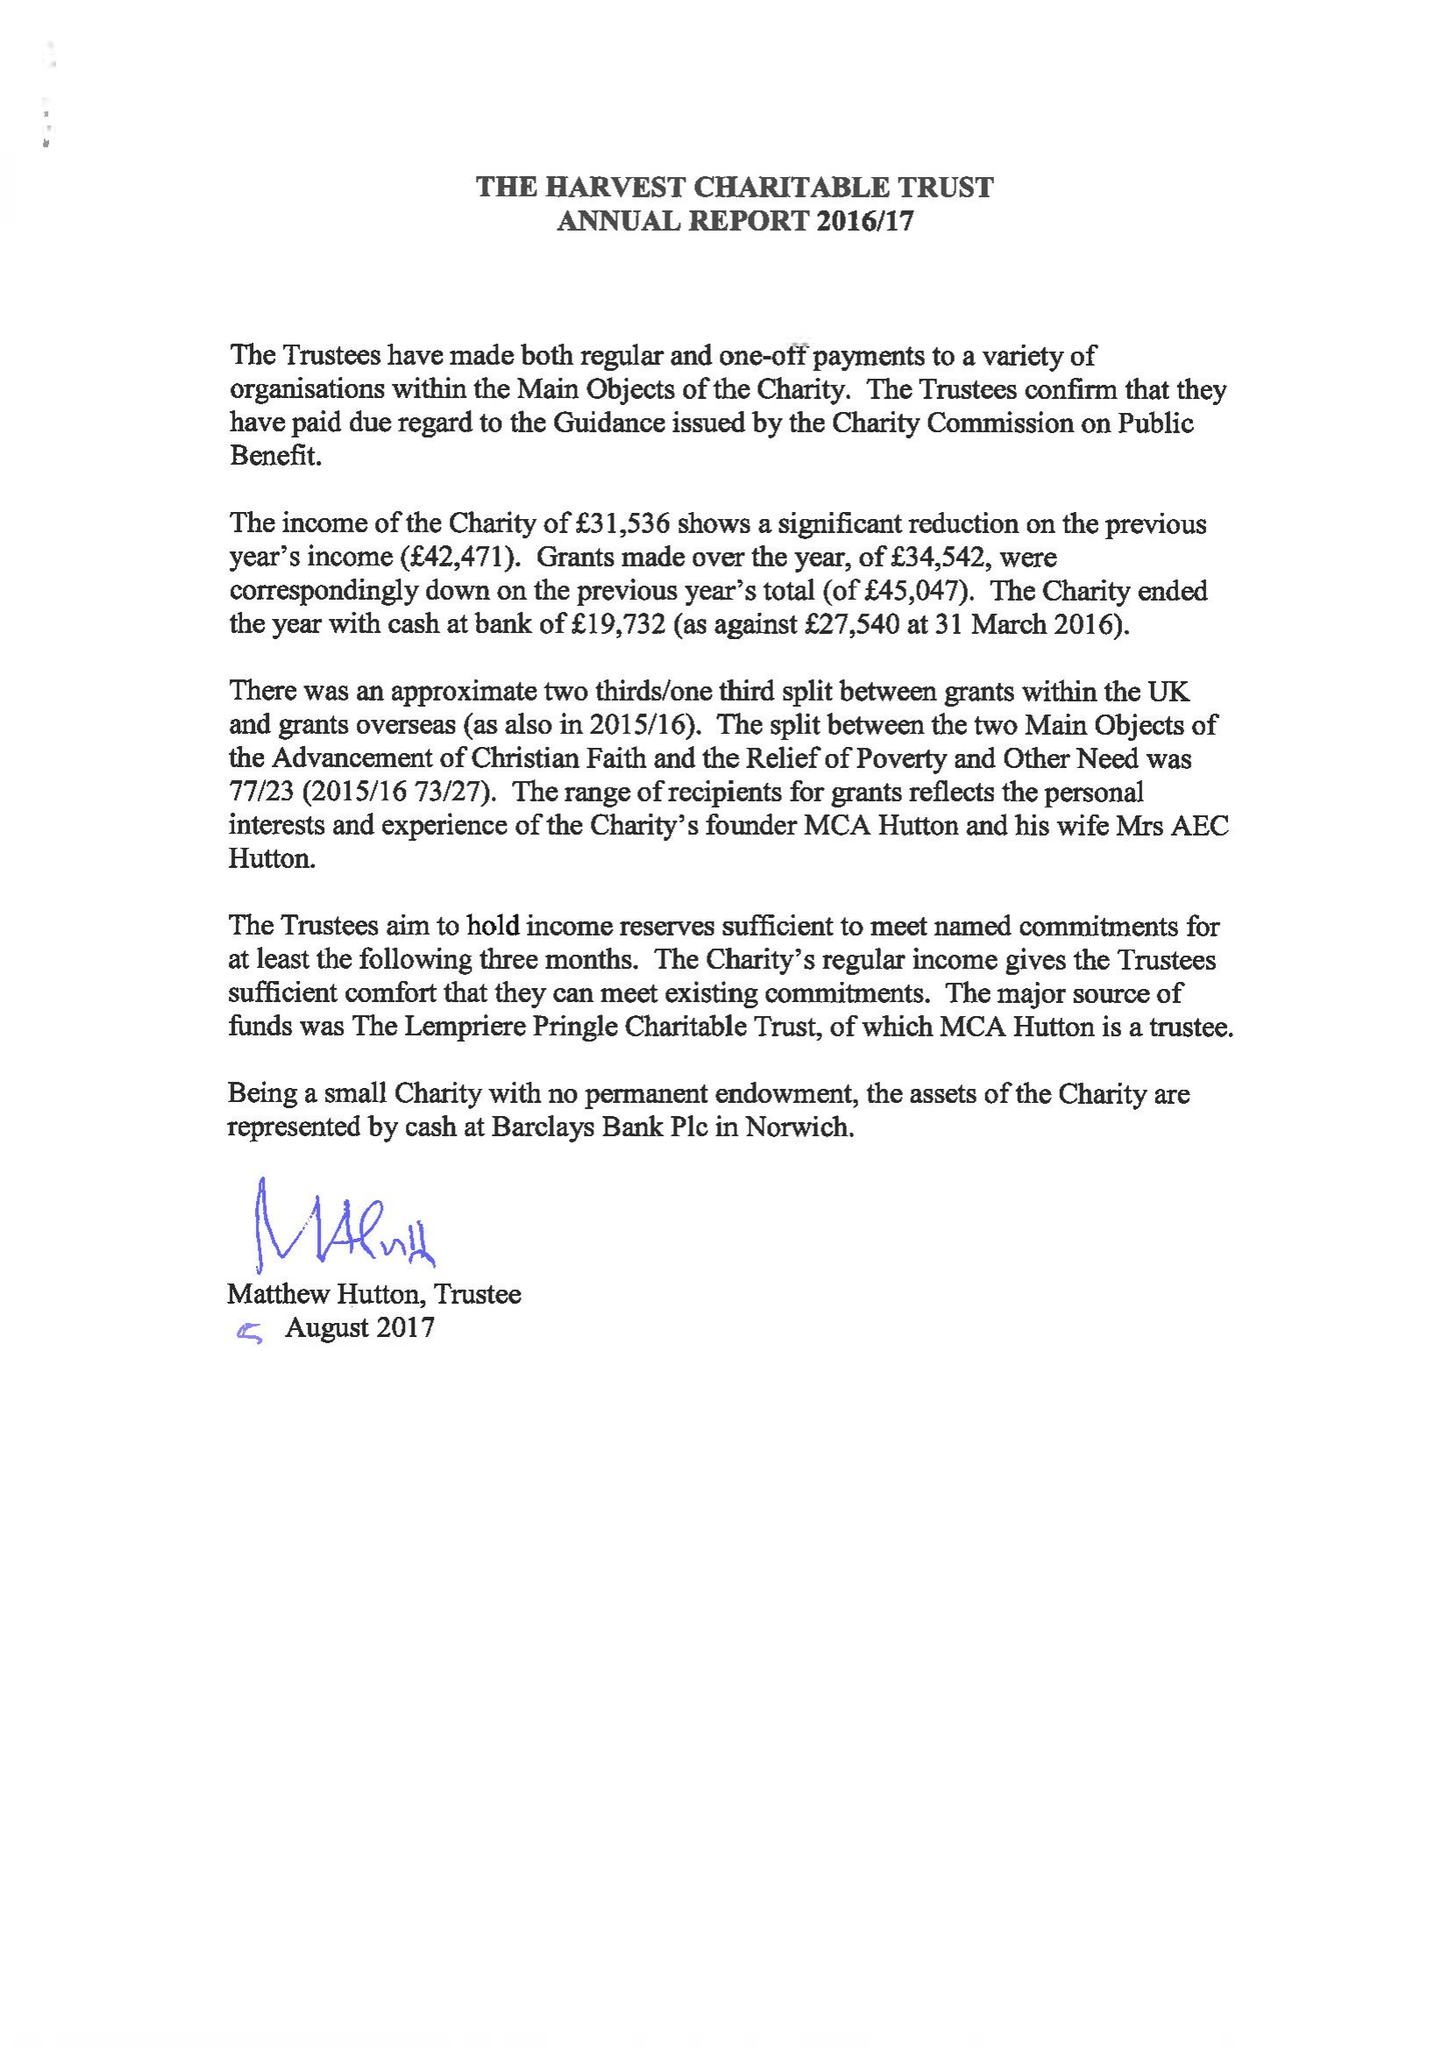What is the value for the income_annually_in_british_pounds?
Answer the question using a single word or phrase. 31536.00 